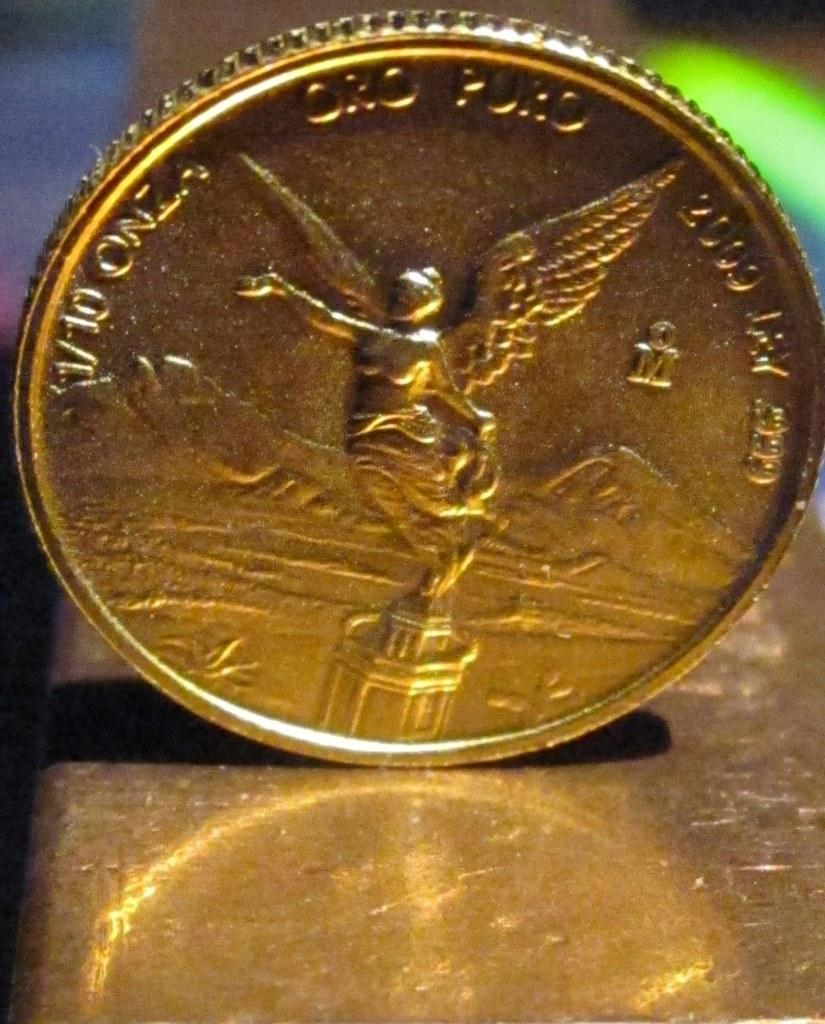<image>
Relay a brief, clear account of the picture shown. A gold coin with V-10 written on the front of it. 